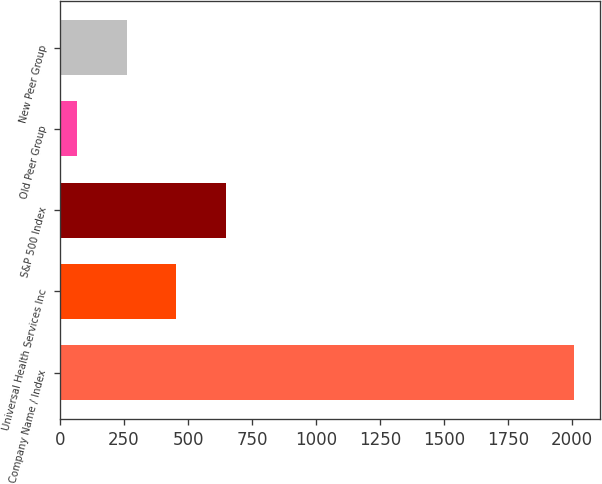<chart> <loc_0><loc_0><loc_500><loc_500><bar_chart><fcel>Company Name / Index<fcel>Universal Health Services Inc<fcel>S&P 500 Index<fcel>Old Peer Group<fcel>New Peer Group<nl><fcel>2007<fcel>454.72<fcel>648.75<fcel>66.66<fcel>260.69<nl></chart> 